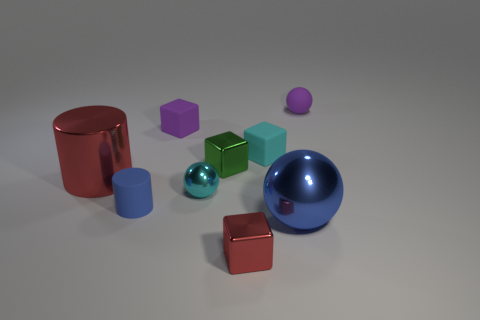Is there a tiny cylinder that has the same color as the big metallic sphere?
Offer a very short reply. Yes. What color is the tiny cylinder?
Your response must be concise. Blue. The tiny sphere that is the same material as the blue cylinder is what color?
Keep it short and to the point. Purple. What number of blue cylinders are the same material as the small red cube?
Your answer should be very brief. 0. There is a rubber ball; how many spheres are on the left side of it?
Ensure brevity in your answer.  2. Is the purple object on the left side of the tiny cyan rubber block made of the same material as the block in front of the matte cylinder?
Provide a succinct answer. No. Are there more metal things that are on the right side of the large cylinder than cyan rubber things to the left of the small green metal thing?
Provide a succinct answer. Yes. There is a tiny cube that is the same color as the matte sphere; what is it made of?
Give a very brief answer. Rubber. Is there anything else that has the same shape as the green object?
Give a very brief answer. Yes. What is the object that is behind the cyan rubber block and on the left side of the large metal ball made of?
Make the answer very short. Rubber. 